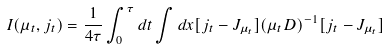Convert formula to latex. <formula><loc_0><loc_0><loc_500><loc_500>I ( \mu _ { t } , j _ { t } ) = \frac { 1 } { 4 \tau } \int _ { 0 } ^ { \tau } d t \int d x [ j _ { t } - J _ { \mu _ { t } } ] ( \mu _ { t } D ) ^ { - 1 } [ j _ { t } - J _ { \mu _ { t } } ]</formula> 